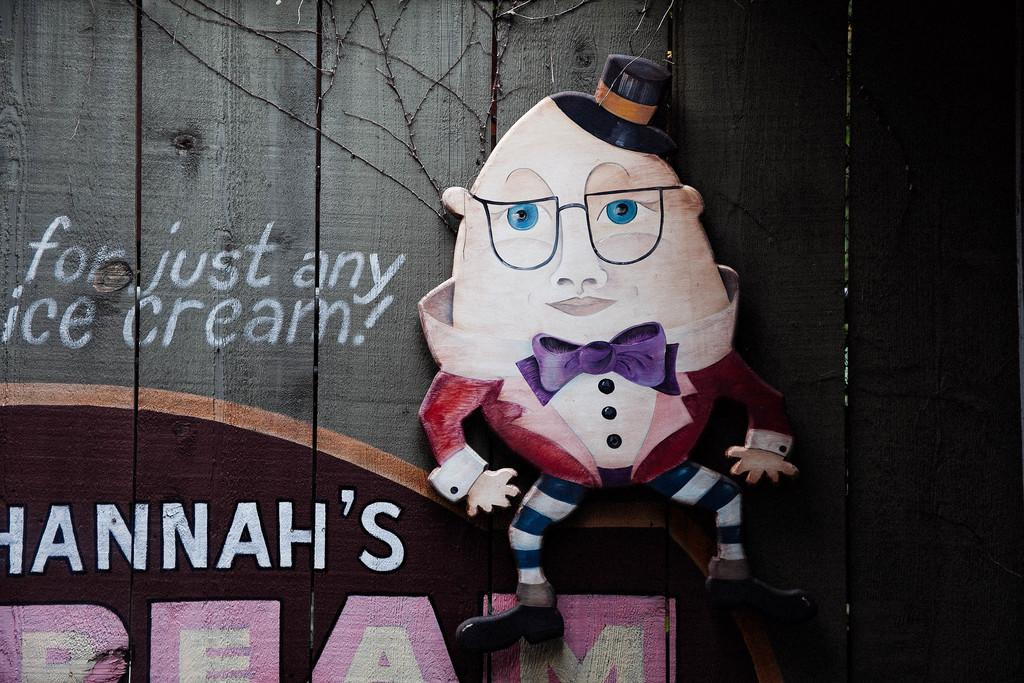What is the main subject of the image? There is a painting in the image. What can be found on the painting? The painting has text and depicts a cartoon character. What type of surface is the painting mounted on? The painting is on a wooden wall. What type of thrill can be seen in the painting? There is no thrill depicted in the painting; it features a cartoon character. 